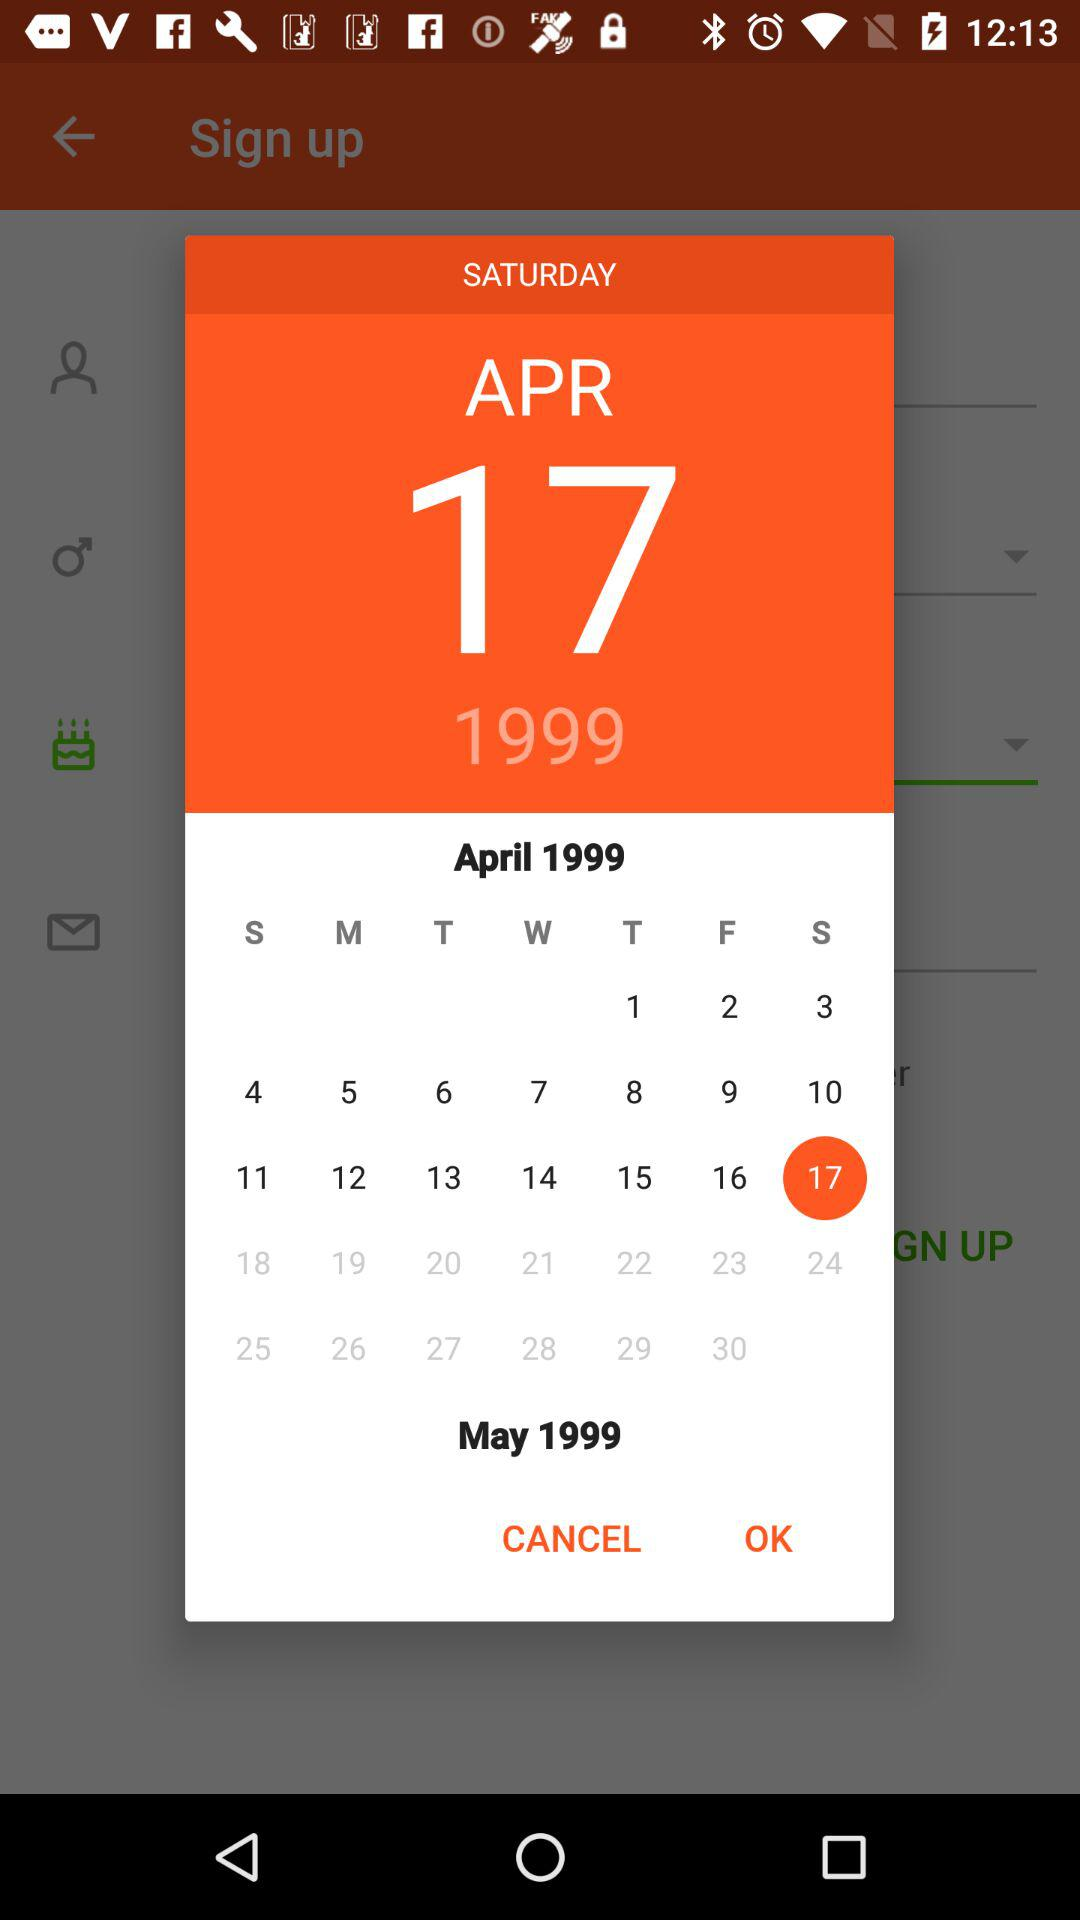Which day falls on April 5th, 1999? The day is Monday. 